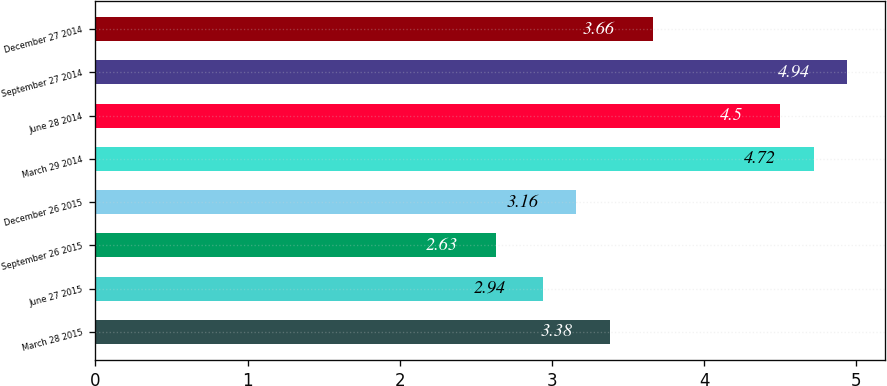<chart> <loc_0><loc_0><loc_500><loc_500><bar_chart><fcel>March 28 2015<fcel>June 27 2015<fcel>September 26 2015<fcel>December 26 2015<fcel>March 29 2014<fcel>June 28 2014<fcel>September 27 2014<fcel>December 27 2014<nl><fcel>3.38<fcel>2.94<fcel>2.63<fcel>3.16<fcel>4.72<fcel>4.5<fcel>4.94<fcel>3.66<nl></chart> 